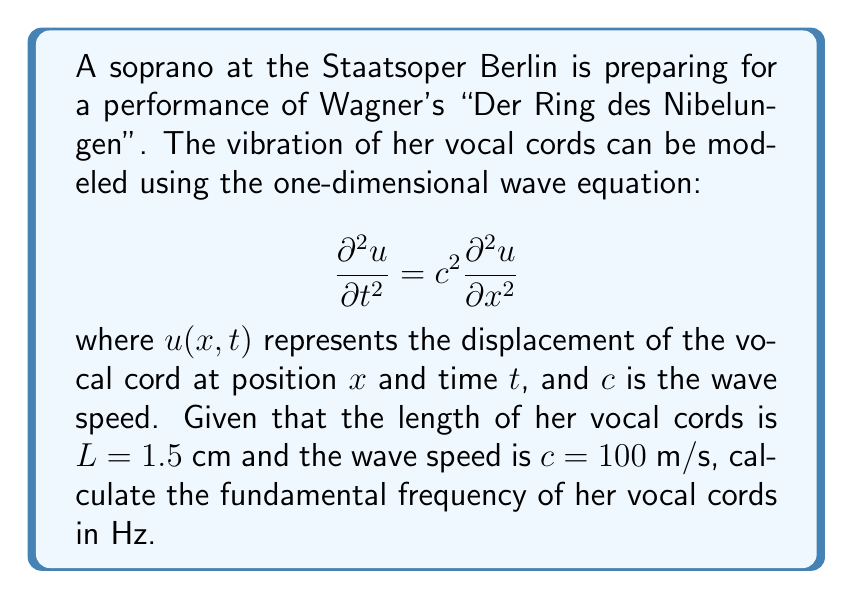Give your solution to this math problem. To solve this problem, we need to follow these steps:

1) The fundamental frequency corresponds to the first mode of vibration for the vocal cords. For a string (or vocal cord) fixed at both ends, the general solution to the wave equation is:

   $$u(x,t) = \sum_{n=1}^{\infty} A_n \sin(\frac{n\pi x}{L}) \cos(\frac{n\pi c t}{L})$$

2) The fundamental frequency corresponds to $n=1$. The angular frequency $\omega$ for this mode is:

   $$\omega = \frac{\pi c}{L}$$

3) We can convert this to frequency $f$ in Hz using the relation $f = \frac{\omega}{2\pi}$:

   $$f = \frac{c}{2L}$$

4) Now, let's substitute the given values:
   $c = 100$ m/s
   $L = 1.5$ cm = $0.015$ m

   $$f = \frac{100}{2(0.015)} = \frac{100}{0.03} = 3333.33 \text{ Hz}$$

5) Rounding to the nearest whole number:

   $$f \approx 3333 \text{ Hz}$$
Answer: 3333 Hz 